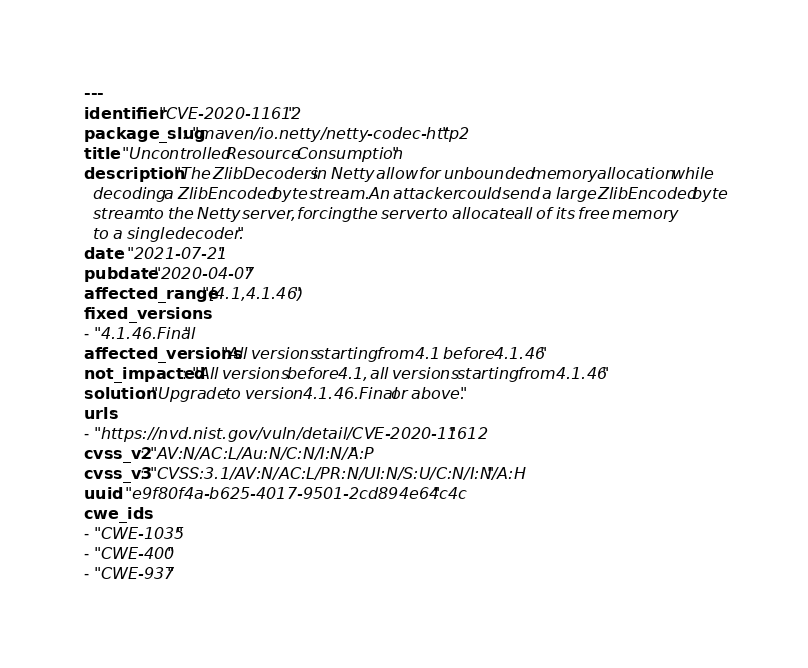Convert code to text. <code><loc_0><loc_0><loc_500><loc_500><_YAML_>---
identifier: "CVE-2020-11612"
package_slug: "maven/io.netty/netty-codec-http2"
title: "Uncontrolled Resource Consumption"
description: "The ZlibDecoders in Netty allow for unbounded memory allocation while
  decoding a ZlibEncoded byte stream. An attacker could send a large ZlibEncoded byte
  stream to the Netty server, forcing the server to allocate all of its free memory
  to a single decoder."
date: "2021-07-21"
pubdate: "2020-04-07"
affected_range: "[4.1,4.1.46)"
fixed_versions:
- "4.1.46.Final"
affected_versions: "All versions starting from 4.1 before 4.1.46"
not_impacted: "All versions before 4.1, all versions starting from 4.1.46"
solution: "Upgrade to version 4.1.46.Final or above."
urls:
- "https://nvd.nist.gov/vuln/detail/CVE-2020-11612"
cvss_v2: "AV:N/AC:L/Au:N/C:N/I:N/A:P"
cvss_v3: "CVSS:3.1/AV:N/AC:L/PR:N/UI:N/S:U/C:N/I:N/A:H"
uuid: "e9f80f4a-b625-4017-9501-2cd894e64c4c"
cwe_ids:
- "CWE-1035"
- "CWE-400"
- "CWE-937"
</code> 